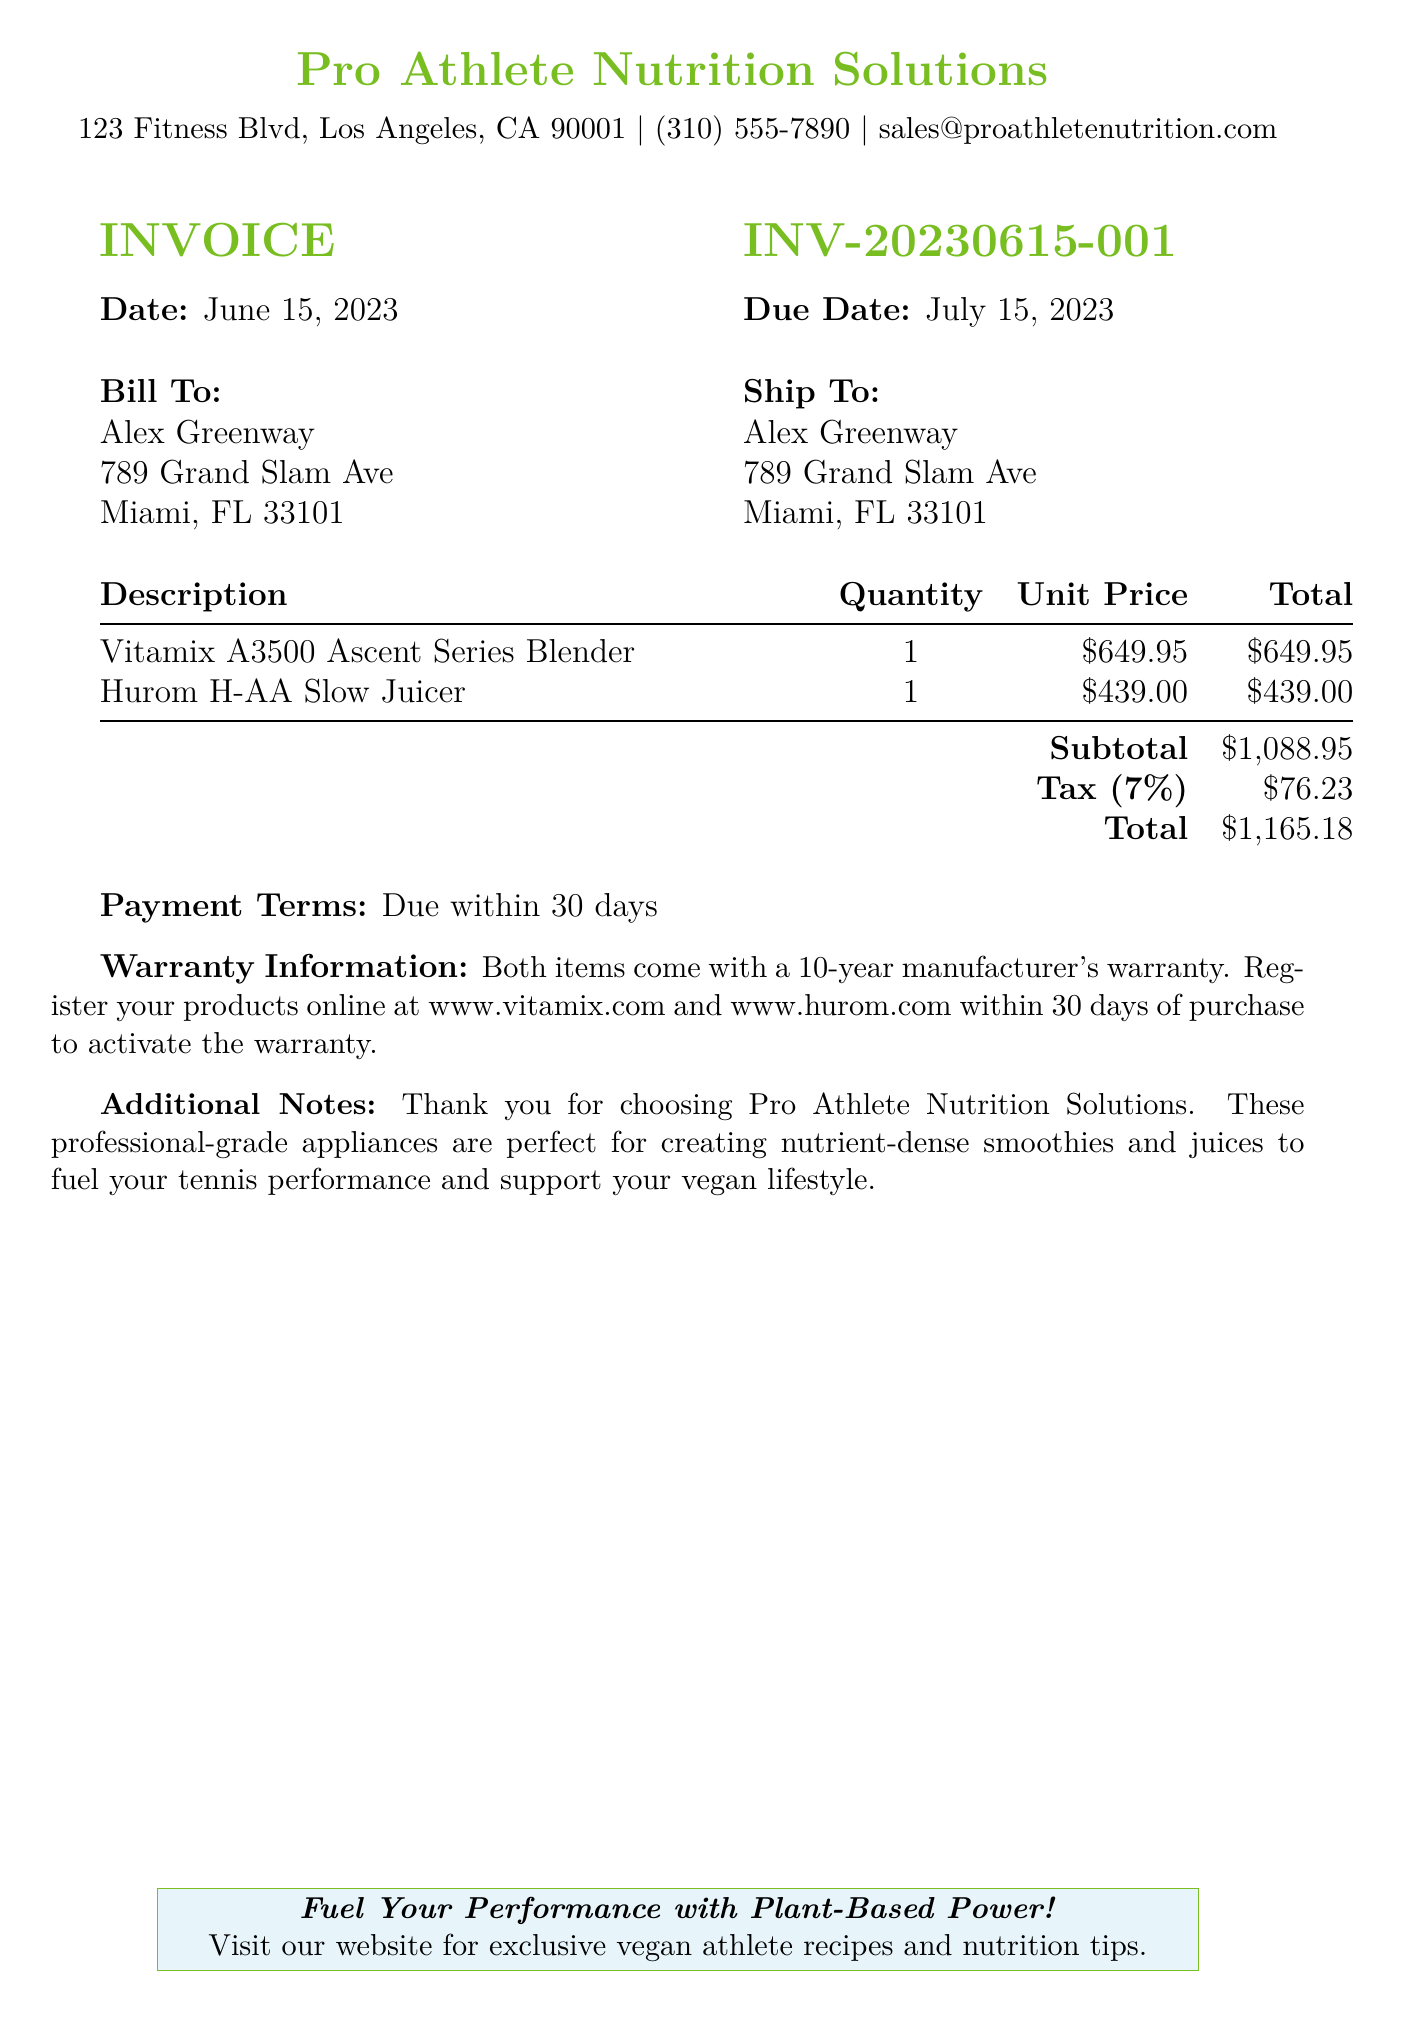What is the invoice number? The invoice number is specified in the document and serves as a unique identifier for the bill, which is INV-20230615-001.
Answer: INV-20230615-001 What is the total amount due? The total due amount is calculated by adding the subtotal and tax, and is listed as the final total on the invoice, which is $1,165.18.
Answer: $1,165.18 What is the due date for payment? The due date is explicitly stated in the document, indicating when the payment must be made, which is July 15, 2023.
Answer: July 15, 2023 How long is the warranty for the products? The warranty duration for the items is explicitly mentioned in the invoice, which is 10 years.
Answer: 10 years Who is the invoice billed to? The invoice is billed to a specific individual whose name and address are provided, which is Alex Greenway.
Answer: Alex Greenway What is the quantity of the Vitamix A3500 Blender? The quantity of each item sold is specified in the document, and for the Vitamix A3500 Blender, it is mentioned as 1.
Answer: 1 What is the subtotal before tax? The subtotal is given directly in the invoice and is calculated before tax is applied, which amounts to $1,088.95.
Answer: $1,088.95 What is the tax percentage applied? The document specifies the tax rate that is applied to the order, which is stated as 7%.
Answer: 7% What is the address for the bill-to person? The invoice provides a full address for the billed individual, which is 789 Grand Slam Ave, Miami, FL 33101.
Answer: 789 Grand Slam Ave, Miami, FL 33101 